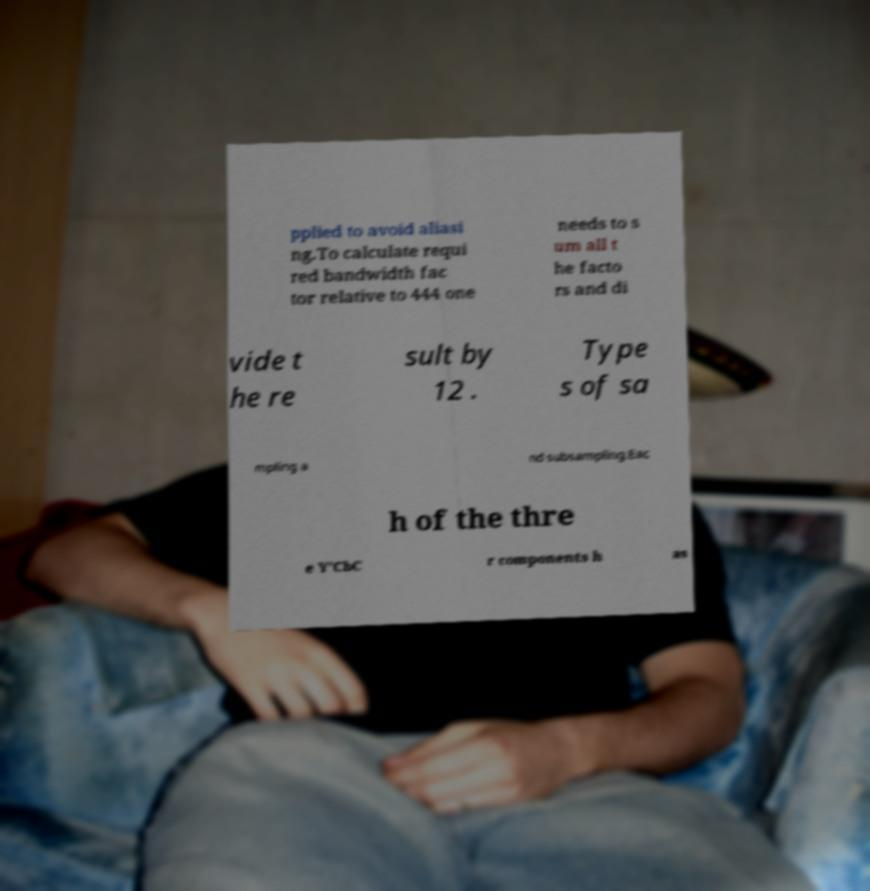What messages or text are displayed in this image? I need them in a readable, typed format. pplied to avoid aliasi ng.To calculate requi red bandwidth fac tor relative to 444 one needs to s um all t he facto rs and di vide t he re sult by 12 . Type s of sa mpling a nd subsampling.Eac h of the thre e Y'CbC r components h as 